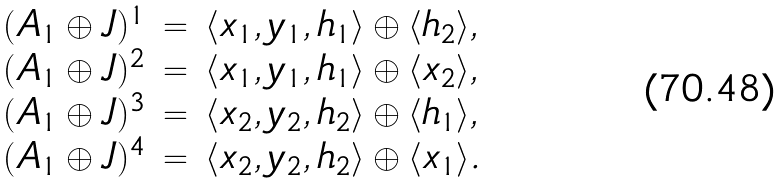<formula> <loc_0><loc_0><loc_500><loc_500>\begin{array} { l l l l l l l l l l } ( A _ { 1 } \oplus J ) ^ { 1 } & = & \langle x _ { 1 } , y _ { 1 } , h _ { 1 } \rangle \oplus \langle h _ { 2 } \rangle , \\ ( A _ { 1 } \oplus J ) ^ { 2 } & = & \langle x _ { 1 } , y _ { 1 } , h _ { 1 } \rangle \oplus \langle x _ { 2 } \rangle , \\ ( A _ { 1 } \oplus J ) ^ { 3 } & = & \langle x _ { 2 } , y _ { 2 } , h _ { 2 } \rangle \oplus \langle h _ { 1 } \rangle , \\ ( A _ { 1 } \oplus J ) ^ { 4 } & = & \langle x _ { 2 } , y _ { 2 } , h _ { 2 } \rangle \oplus \langle x _ { 1 } \rangle . \end{array}</formula> 